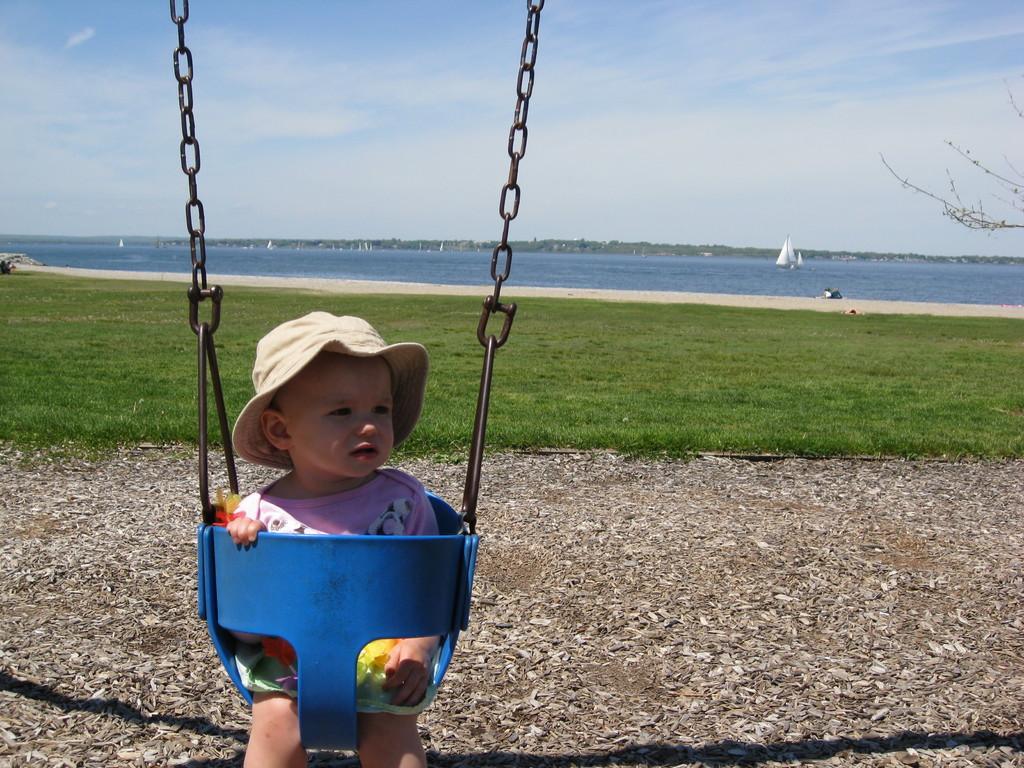Please provide a concise description of this image. In the foreground of this image, there is a baby wearing hat is sitting on a swing. In the background, there is a grass land, water, few boats on the water, greenery, sky and the cloud. 